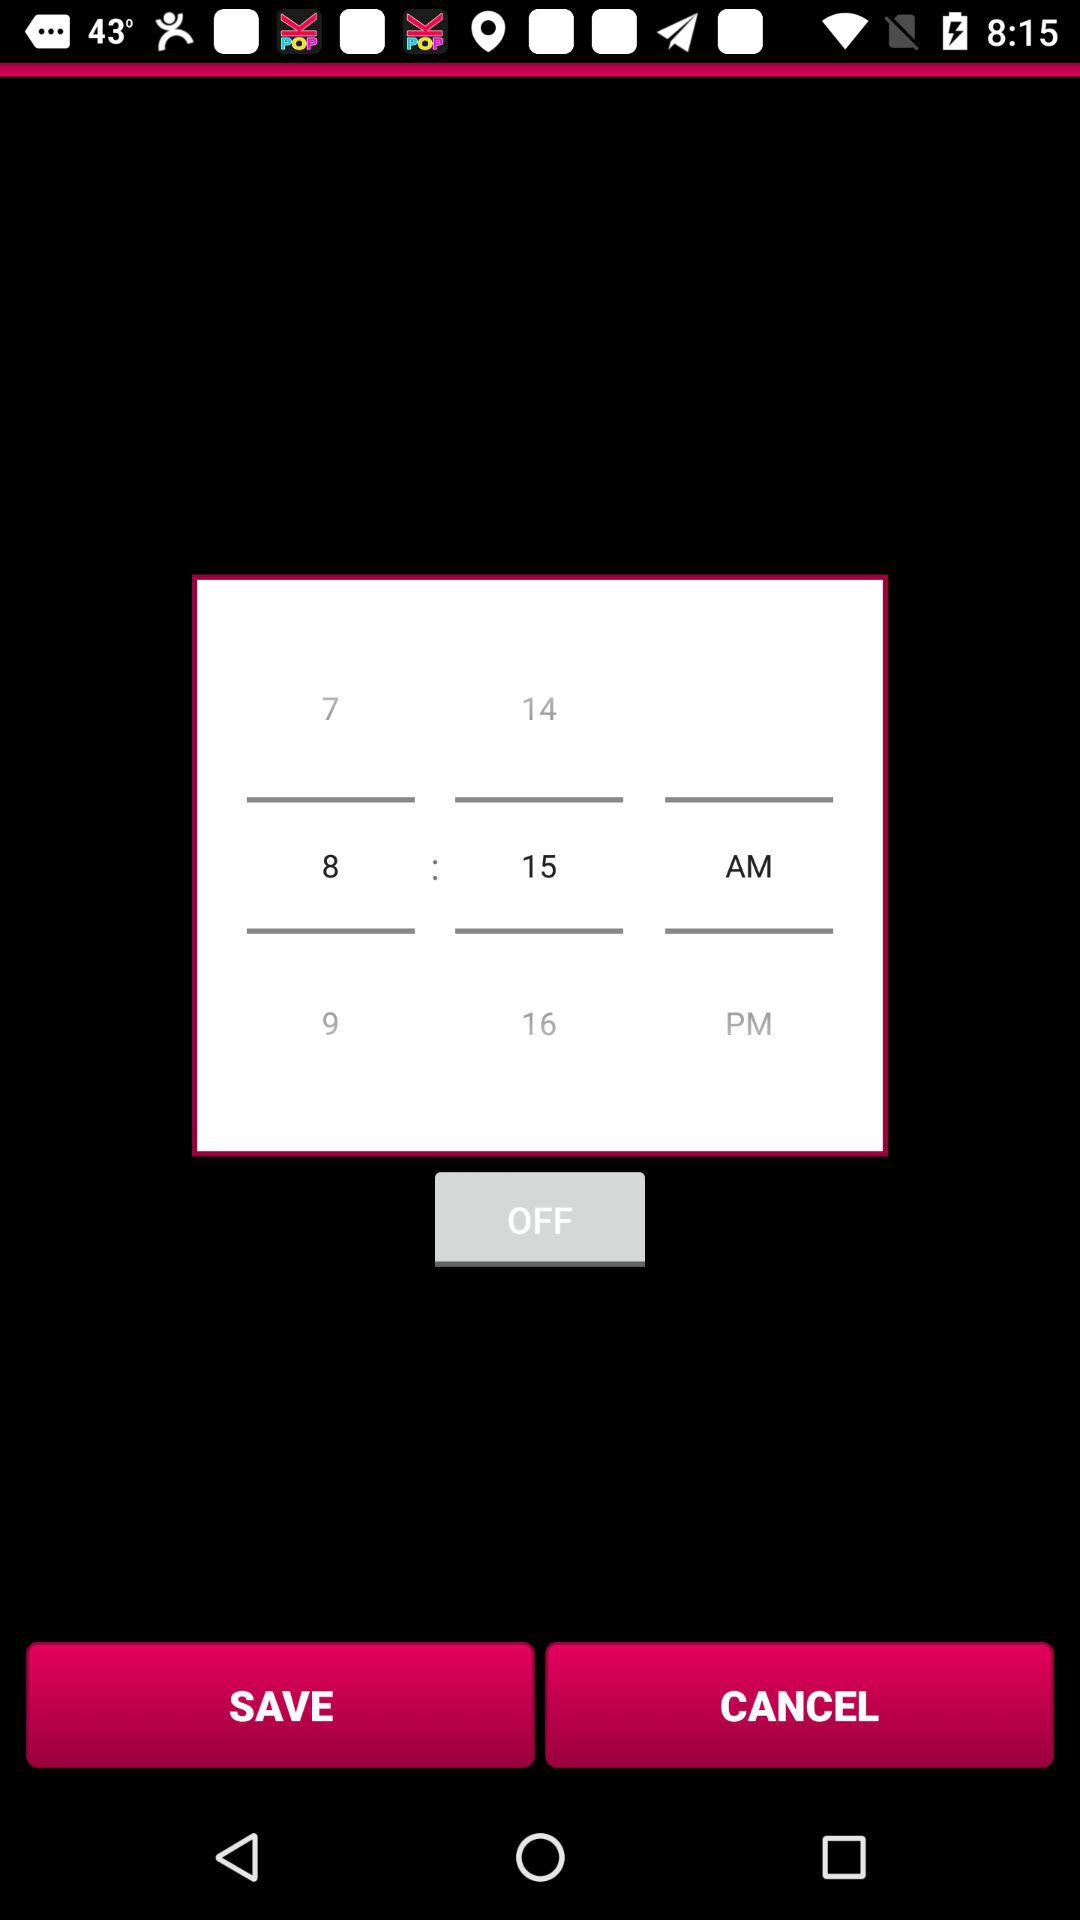What is the selected time? The selected time is 8: 15 AM. 